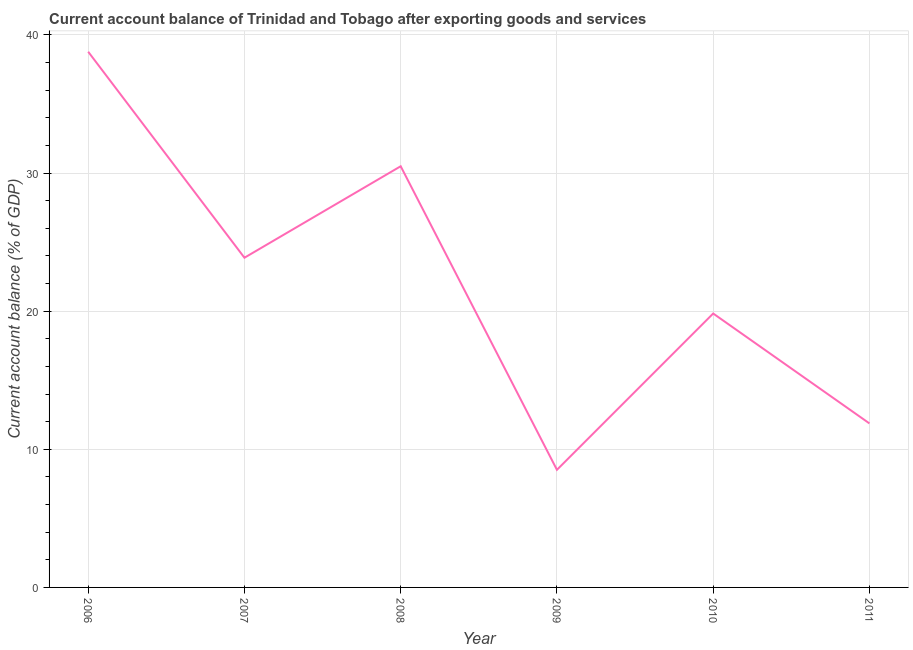What is the current account balance in 2007?
Your response must be concise. 23.87. Across all years, what is the maximum current account balance?
Make the answer very short. 38.79. Across all years, what is the minimum current account balance?
Provide a short and direct response. 8.52. In which year was the current account balance maximum?
Give a very brief answer. 2006. In which year was the current account balance minimum?
Your response must be concise. 2009. What is the sum of the current account balance?
Your response must be concise. 133.38. What is the difference between the current account balance in 2006 and 2008?
Offer a terse response. 8.29. What is the average current account balance per year?
Offer a very short reply. 22.23. What is the median current account balance?
Your response must be concise. 21.85. Do a majority of the years between 2009 and 2010 (inclusive) have current account balance greater than 18 %?
Your answer should be very brief. No. What is the ratio of the current account balance in 2006 to that in 2011?
Provide a short and direct response. 3.27. Is the current account balance in 2006 less than that in 2008?
Your response must be concise. No. Is the difference between the current account balance in 2007 and 2008 greater than the difference between any two years?
Provide a succinct answer. No. What is the difference between the highest and the second highest current account balance?
Your answer should be compact. 8.29. Is the sum of the current account balance in 2007 and 2008 greater than the maximum current account balance across all years?
Your answer should be compact. Yes. What is the difference between the highest and the lowest current account balance?
Ensure brevity in your answer.  30.27. In how many years, is the current account balance greater than the average current account balance taken over all years?
Ensure brevity in your answer.  3. Does the current account balance monotonically increase over the years?
Give a very brief answer. No. What is the difference between two consecutive major ticks on the Y-axis?
Give a very brief answer. 10. Are the values on the major ticks of Y-axis written in scientific E-notation?
Offer a very short reply. No. Does the graph contain any zero values?
Provide a short and direct response. No. What is the title of the graph?
Provide a succinct answer. Current account balance of Trinidad and Tobago after exporting goods and services. What is the label or title of the X-axis?
Provide a succinct answer. Year. What is the label or title of the Y-axis?
Offer a terse response. Current account balance (% of GDP). What is the Current account balance (% of GDP) in 2006?
Your response must be concise. 38.79. What is the Current account balance (% of GDP) in 2007?
Provide a succinct answer. 23.87. What is the Current account balance (% of GDP) in 2008?
Give a very brief answer. 30.5. What is the Current account balance (% of GDP) of 2009?
Give a very brief answer. 8.52. What is the Current account balance (% of GDP) of 2010?
Keep it short and to the point. 19.83. What is the Current account balance (% of GDP) in 2011?
Give a very brief answer. 11.87. What is the difference between the Current account balance (% of GDP) in 2006 and 2007?
Your answer should be compact. 14.92. What is the difference between the Current account balance (% of GDP) in 2006 and 2008?
Make the answer very short. 8.29. What is the difference between the Current account balance (% of GDP) in 2006 and 2009?
Provide a succinct answer. 30.27. What is the difference between the Current account balance (% of GDP) in 2006 and 2010?
Give a very brief answer. 18.95. What is the difference between the Current account balance (% of GDP) in 2006 and 2011?
Ensure brevity in your answer.  26.91. What is the difference between the Current account balance (% of GDP) in 2007 and 2008?
Offer a terse response. -6.62. What is the difference between the Current account balance (% of GDP) in 2007 and 2009?
Provide a succinct answer. 15.36. What is the difference between the Current account balance (% of GDP) in 2007 and 2010?
Provide a short and direct response. 4.04. What is the difference between the Current account balance (% of GDP) in 2007 and 2011?
Offer a terse response. 12. What is the difference between the Current account balance (% of GDP) in 2008 and 2009?
Your answer should be compact. 21.98. What is the difference between the Current account balance (% of GDP) in 2008 and 2010?
Make the answer very short. 10.66. What is the difference between the Current account balance (% of GDP) in 2008 and 2011?
Your answer should be very brief. 18.62. What is the difference between the Current account balance (% of GDP) in 2009 and 2010?
Make the answer very short. -11.32. What is the difference between the Current account balance (% of GDP) in 2009 and 2011?
Give a very brief answer. -3.36. What is the difference between the Current account balance (% of GDP) in 2010 and 2011?
Give a very brief answer. 7.96. What is the ratio of the Current account balance (% of GDP) in 2006 to that in 2007?
Provide a succinct answer. 1.62. What is the ratio of the Current account balance (% of GDP) in 2006 to that in 2008?
Provide a short and direct response. 1.27. What is the ratio of the Current account balance (% of GDP) in 2006 to that in 2009?
Your answer should be compact. 4.55. What is the ratio of the Current account balance (% of GDP) in 2006 to that in 2010?
Provide a short and direct response. 1.96. What is the ratio of the Current account balance (% of GDP) in 2006 to that in 2011?
Provide a short and direct response. 3.27. What is the ratio of the Current account balance (% of GDP) in 2007 to that in 2008?
Give a very brief answer. 0.78. What is the ratio of the Current account balance (% of GDP) in 2007 to that in 2009?
Ensure brevity in your answer.  2.8. What is the ratio of the Current account balance (% of GDP) in 2007 to that in 2010?
Offer a very short reply. 1.2. What is the ratio of the Current account balance (% of GDP) in 2007 to that in 2011?
Give a very brief answer. 2.01. What is the ratio of the Current account balance (% of GDP) in 2008 to that in 2009?
Offer a terse response. 3.58. What is the ratio of the Current account balance (% of GDP) in 2008 to that in 2010?
Offer a very short reply. 1.54. What is the ratio of the Current account balance (% of GDP) in 2008 to that in 2011?
Ensure brevity in your answer.  2.57. What is the ratio of the Current account balance (% of GDP) in 2009 to that in 2010?
Make the answer very short. 0.43. What is the ratio of the Current account balance (% of GDP) in 2009 to that in 2011?
Offer a very short reply. 0.72. What is the ratio of the Current account balance (% of GDP) in 2010 to that in 2011?
Your response must be concise. 1.67. 